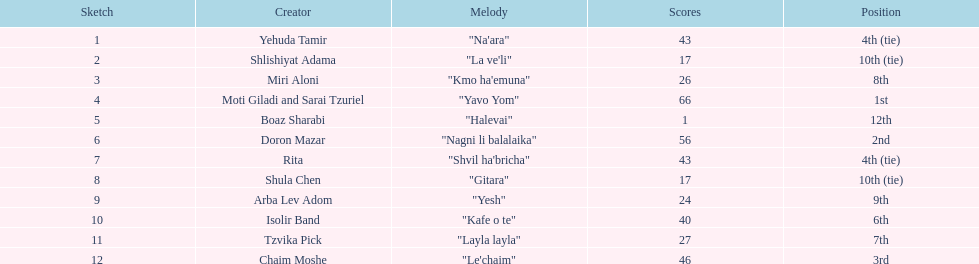What song is listed in the table right before layla layla? "Kafe o te". 